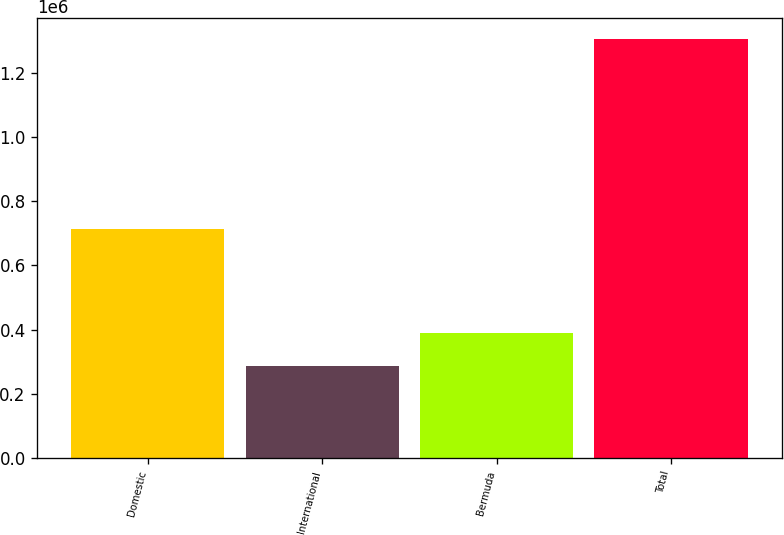<chart> <loc_0><loc_0><loc_500><loc_500><bar_chart><fcel>Domestic<fcel>International<fcel>Bermuda<fcel>Total<nl><fcel>712568<fcel>287688<fcel>389316<fcel>1.30396e+06<nl></chart> 